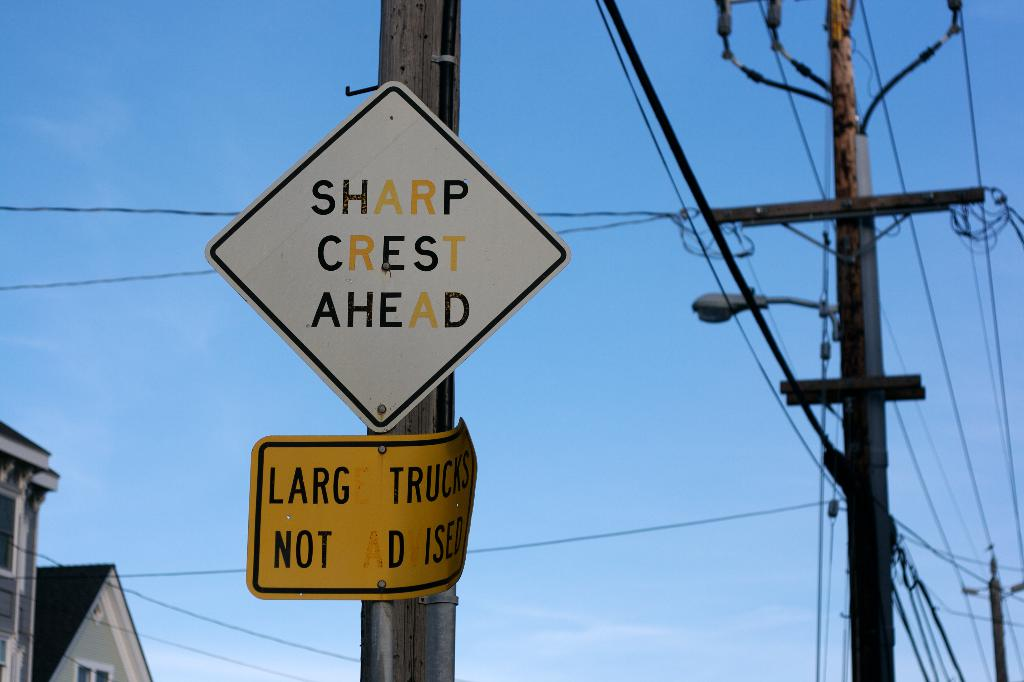Provide a one-sentence caption for the provided image. A warning sign reading 'SHARP CREST AHEAD' is mounted on a utility pole above a secondary sign indicating 'LARGE TRUCKS NOT ADVISED', set against a clear sky with power lines and house rooftops in the background. 